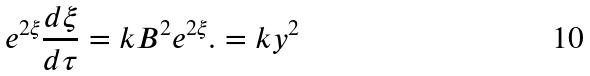<formula> <loc_0><loc_0><loc_500><loc_500>e ^ { 2 \xi } \frac { d \xi } { d \tau } = k B ^ { 2 } e ^ { 2 \xi } . = k y ^ { 2 }</formula> 